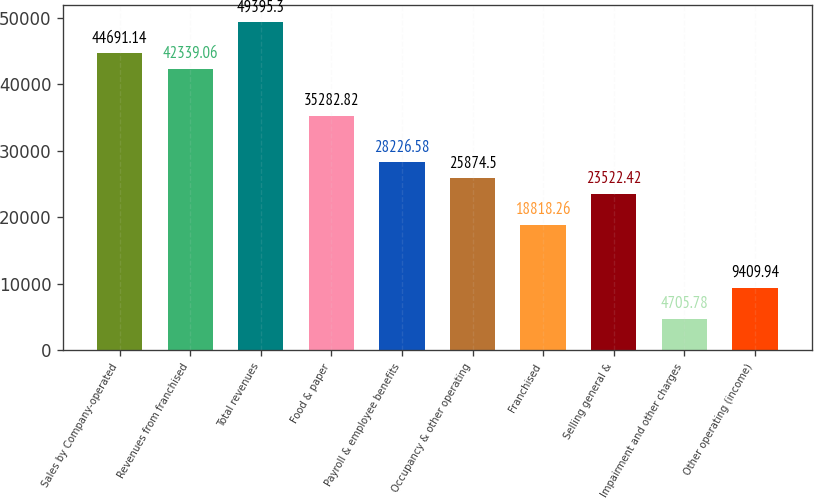<chart> <loc_0><loc_0><loc_500><loc_500><bar_chart><fcel>Sales by Company-operated<fcel>Revenues from franchised<fcel>Total revenues<fcel>Food & paper<fcel>Payroll & employee benefits<fcel>Occupancy & other operating<fcel>Franchised<fcel>Selling general &<fcel>Impairment and other charges<fcel>Other operating (income)<nl><fcel>44691.1<fcel>42339.1<fcel>49395.3<fcel>35282.8<fcel>28226.6<fcel>25874.5<fcel>18818.3<fcel>23522.4<fcel>4705.78<fcel>9409.94<nl></chart> 